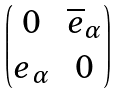Convert formula to latex. <formula><loc_0><loc_0><loc_500><loc_500>\begin{pmatrix} 0 & \overline { e } _ { \alpha } \\ { e } _ { \alpha } & 0 \end{pmatrix}</formula> 